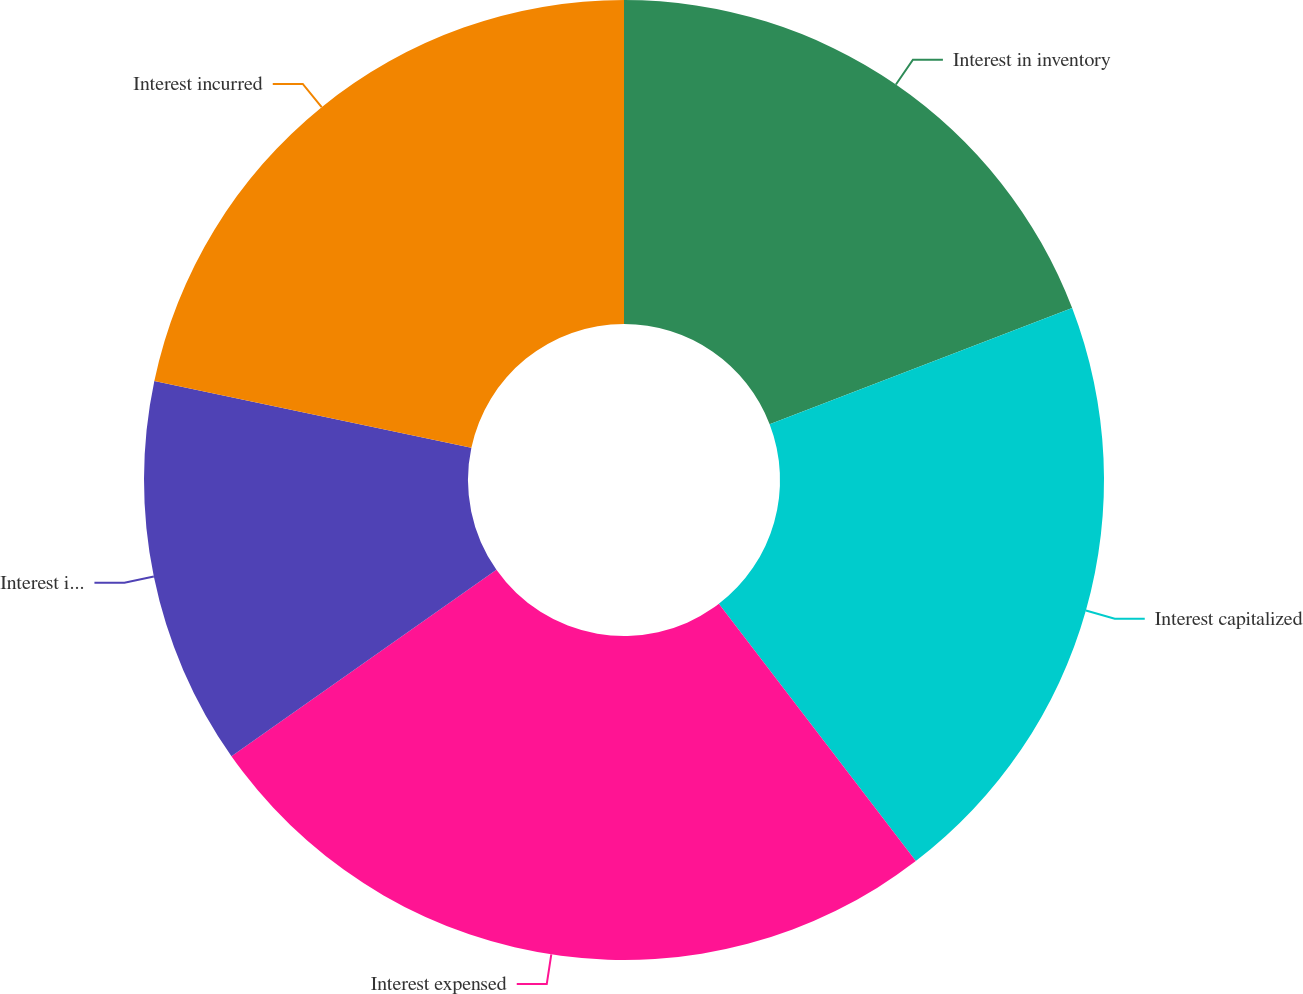<chart> <loc_0><loc_0><loc_500><loc_500><pie_chart><fcel>Interest in inventory<fcel>Interest capitalized<fcel>Interest expensed<fcel>Interest in inventory end of<fcel>Interest incurred<nl><fcel>19.17%<fcel>20.43%<fcel>25.64%<fcel>13.07%<fcel>21.69%<nl></chart> 